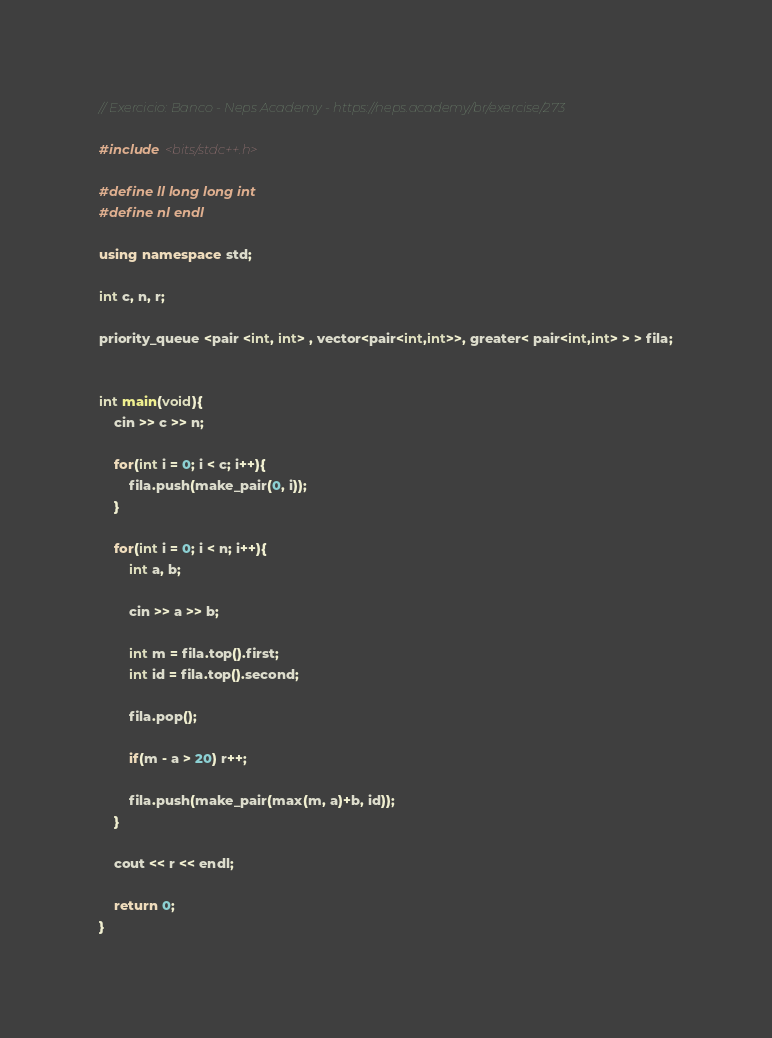Convert code to text. <code><loc_0><loc_0><loc_500><loc_500><_C++_>// Exercicio: Banco - Neps Academy - https://neps.academy/br/exercise/273

#include <bits/stdc++.h>

#define ll long long int
#define nl endl

using namespace std;

int c, n, r;

priority_queue <pair <int, int> , vector<pair<int,int>>, greater< pair<int,int> > > fila;


int main(void){
    cin >> c >> n;

    for(int i = 0; i < c; i++){ 
        fila.push(make_pair(0, i));
    }

    for(int i = 0; i < n; i++){
        int a, b;

        cin >> a >> b;

        int m = fila.top().first;
        int id = fila.top().second;

        fila.pop();

        if(m - a > 20) r++;

        fila.push(make_pair(max(m, a)+b, id));
    }

    cout << r << endl;

    return 0;
}</code> 